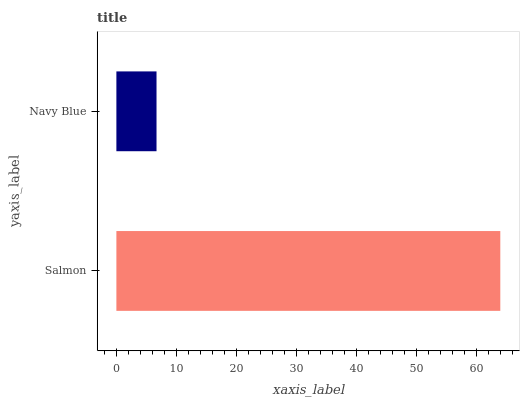Is Navy Blue the minimum?
Answer yes or no. Yes. Is Salmon the maximum?
Answer yes or no. Yes. Is Navy Blue the maximum?
Answer yes or no. No. Is Salmon greater than Navy Blue?
Answer yes or no. Yes. Is Navy Blue less than Salmon?
Answer yes or no. Yes. Is Navy Blue greater than Salmon?
Answer yes or no. No. Is Salmon less than Navy Blue?
Answer yes or no. No. Is Salmon the high median?
Answer yes or no. Yes. Is Navy Blue the low median?
Answer yes or no. Yes. Is Navy Blue the high median?
Answer yes or no. No. Is Salmon the low median?
Answer yes or no. No. 